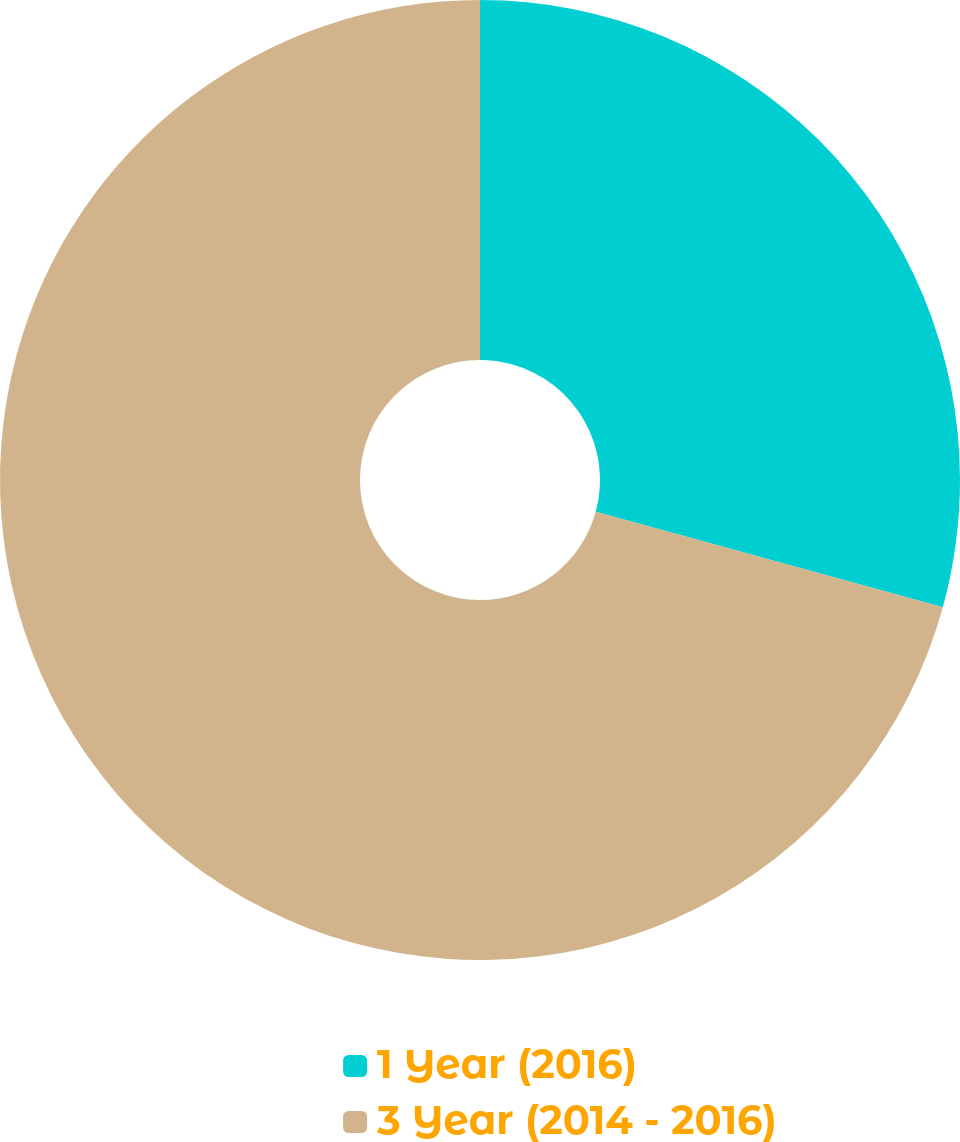Convert chart. <chart><loc_0><loc_0><loc_500><loc_500><pie_chart><fcel>1 Year (2016)<fcel>3 Year (2014 - 2016)<nl><fcel>29.27%<fcel>70.73%<nl></chart> 